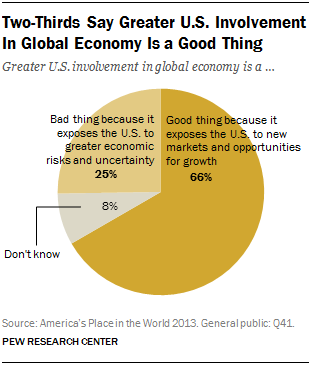Identify some key points in this picture. The sum of the two smallest segments is equal to the average of all the segments. Eight percent of respondents did not know the answer. 